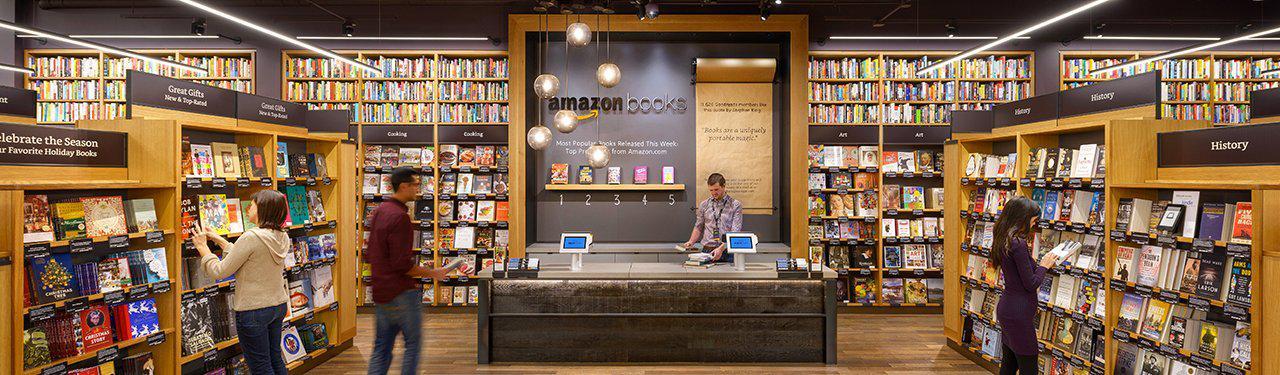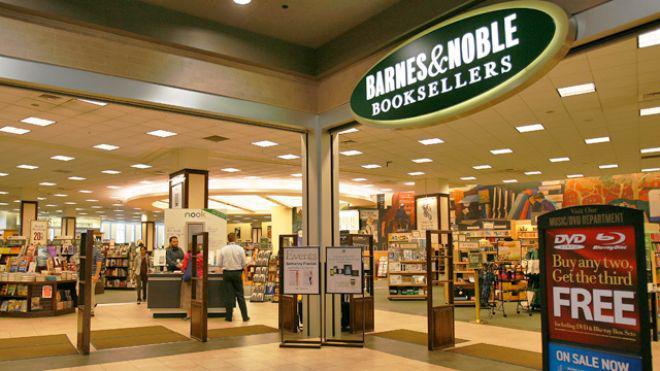The first image is the image on the left, the second image is the image on the right. Examine the images to the left and right. Is the description "There is exactly one person." accurate? Answer yes or no. No. The first image is the image on the left, the second image is the image on the right. For the images displayed, is the sentence "Someone is standing while reading a book." factually correct? Answer yes or no. Yes. 